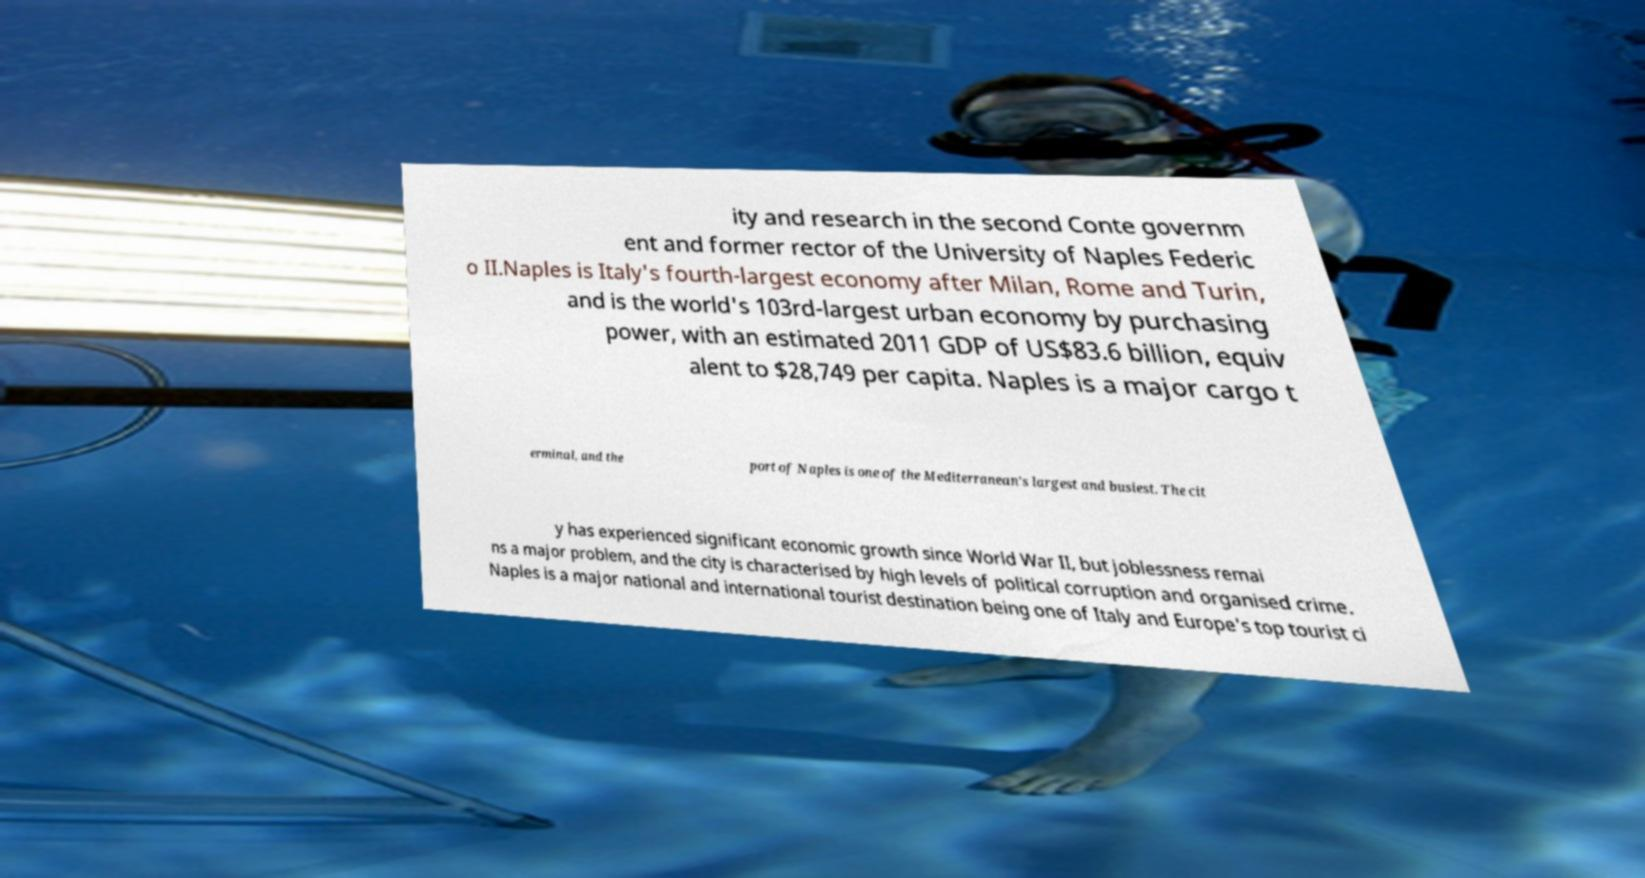Could you assist in decoding the text presented in this image and type it out clearly? ity and research in the second Conte governm ent and former rector of the University of Naples Federic o II.Naples is Italy's fourth-largest economy after Milan, Rome and Turin, and is the world's 103rd-largest urban economy by purchasing power, with an estimated 2011 GDP of US$83.6 billion, equiv alent to $28,749 per capita. Naples is a major cargo t erminal, and the port of Naples is one of the Mediterranean's largest and busiest. The cit y has experienced significant economic growth since World War II, but joblessness remai ns a major problem, and the city is characterised by high levels of political corruption and organised crime. Naples is a major national and international tourist destination being one of Italy and Europe's top tourist ci 